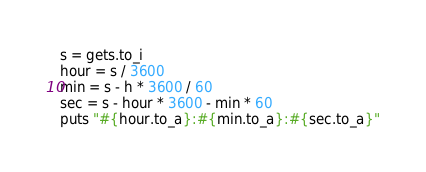<code> <loc_0><loc_0><loc_500><loc_500><_Ruby_>s = gets.to_i
hour = s / 3600
min = s - h * 3600 / 60
sec = s - hour * 3600 - min * 60
puts "#{hour.to_a}:#{min.to_a}:#{sec.to_a}"</code> 